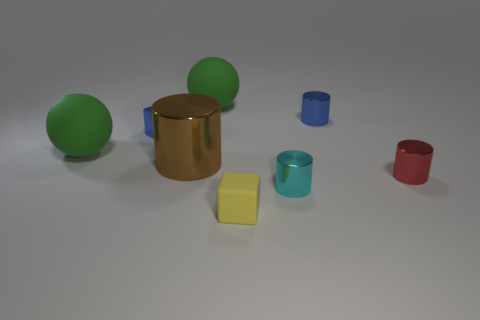Add 1 green balls. How many objects exist? 9 Subtract all spheres. How many objects are left? 6 Subtract 0 red spheres. How many objects are left? 8 Subtract all blue cylinders. Subtract all yellow things. How many objects are left? 6 Add 6 large metal cylinders. How many large metal cylinders are left? 7 Add 6 big matte things. How many big matte things exist? 8 